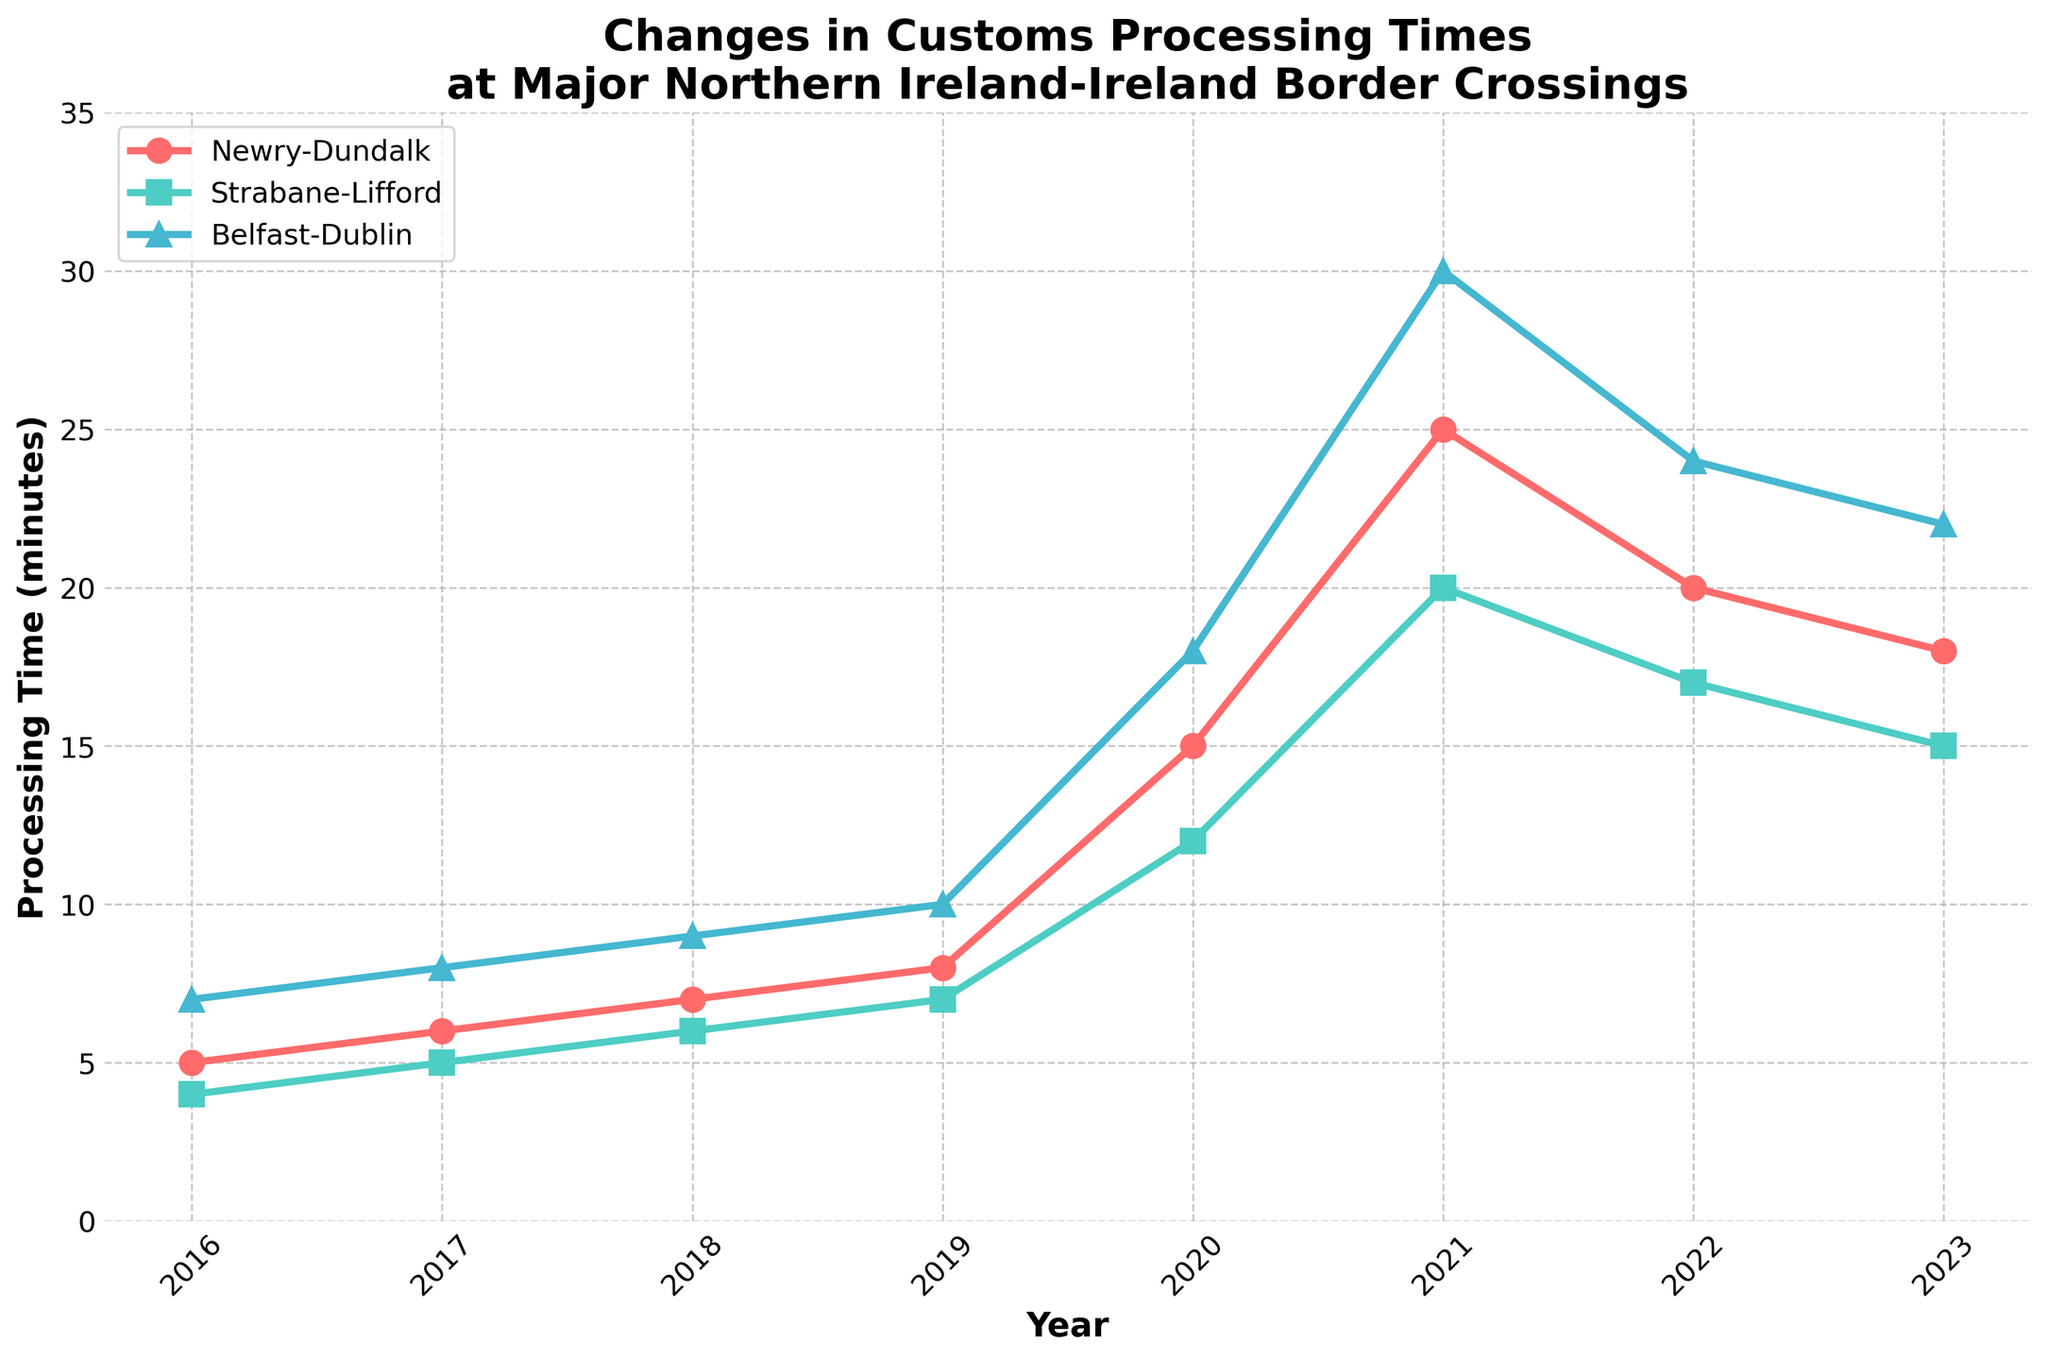What is the overall trend in customs processing times at the Newry-Dundalk crossing from 2016 to 2023? Observing the line for Newry-Dundalk, it starts at 5 minutes in 2016, peaks at 25 minutes in 2021, and then declines to 18 minutes in 2023. Thus, the overall trend is an increase followed by a decrease.
Answer: Increase followed by a decrease Which year had the highest customs processing time for the Strabane-Lifford crossing? By examining the line for Strabane-Lifford, it's visible that the highest point is in 2021 with a processing time of 20 minutes.
Answer: 2021 How does the processing time at the Belfast-Dublin crossing in 2023 compare to 2016? In 2023, the processing time is 22 minutes, while in 2016 it was 7 minutes. This shows an increase of 15 minutes.
Answer: It increased by 15 minutes What is the average processing time at all crossings in 2020? The processing times in 2020 are 15 minutes (Newry-Dundalk), 12 minutes (Strabane-Lifford), and 18 minutes (Belfast-Dublin). The average is calculated as (15 + 12 + 18) / 3 = 45 / 3 = 15 minutes.
Answer: 15 minutes By how many minutes did the customs processing time at the Newry-Dundalk crossing increase between 2016 and 2021? The processing time in 2016 is 5 minutes and in 2021 it is 25 minutes. The increase can be computed as 25 - 5 = 20 minutes.
Answer: 20 minutes Which crossing had the least increase in processing time from 2016 to 2021? Newry-Dundalk increased from 5 to 25 minutes (20 minutes increase), Strabane-Lifford increased from 4 to 20 minutes (16 minutes increase), and Belfast-Dublin increased from 7 to 30 minutes (23 minutes increase). Therefore, Strabane-Lifford had the least increase of 16 minutes.
Answer: Strabane-Lifford What was the difference in processing time at the Strabane-Lifford crossing between 2022 and 2023? The processing time in 2022 is 17 minutes, and in 2023 it is 15 minutes. The difference is 17 - 15 = 2 minutes.
Answer: 2 minutes Which year saw the sharpest increase in processing times for the Belfast-Dublin crossing? Checking the slope of the Belfast-Dublin line, the sharpest increase appears between 2019 (10 minutes) and 2020 (18 minutes), which is an 8-minute rise.
Answer: From 2019 to 2020 In which year did all crossings experience a peak in their processing times? By examining the peaks of each line, all crossings reached their maximum processing times in 2021.
Answer: 2021 What is the sum of customs processing times at Strabane-Lifford from 2016 to 2023? Summing up the Strabane-Lifford times: 4 + 5 + 6 + 7 + 12 + 20 + 17 + 15 = 86 minutes.
Answer: 86 minutes 